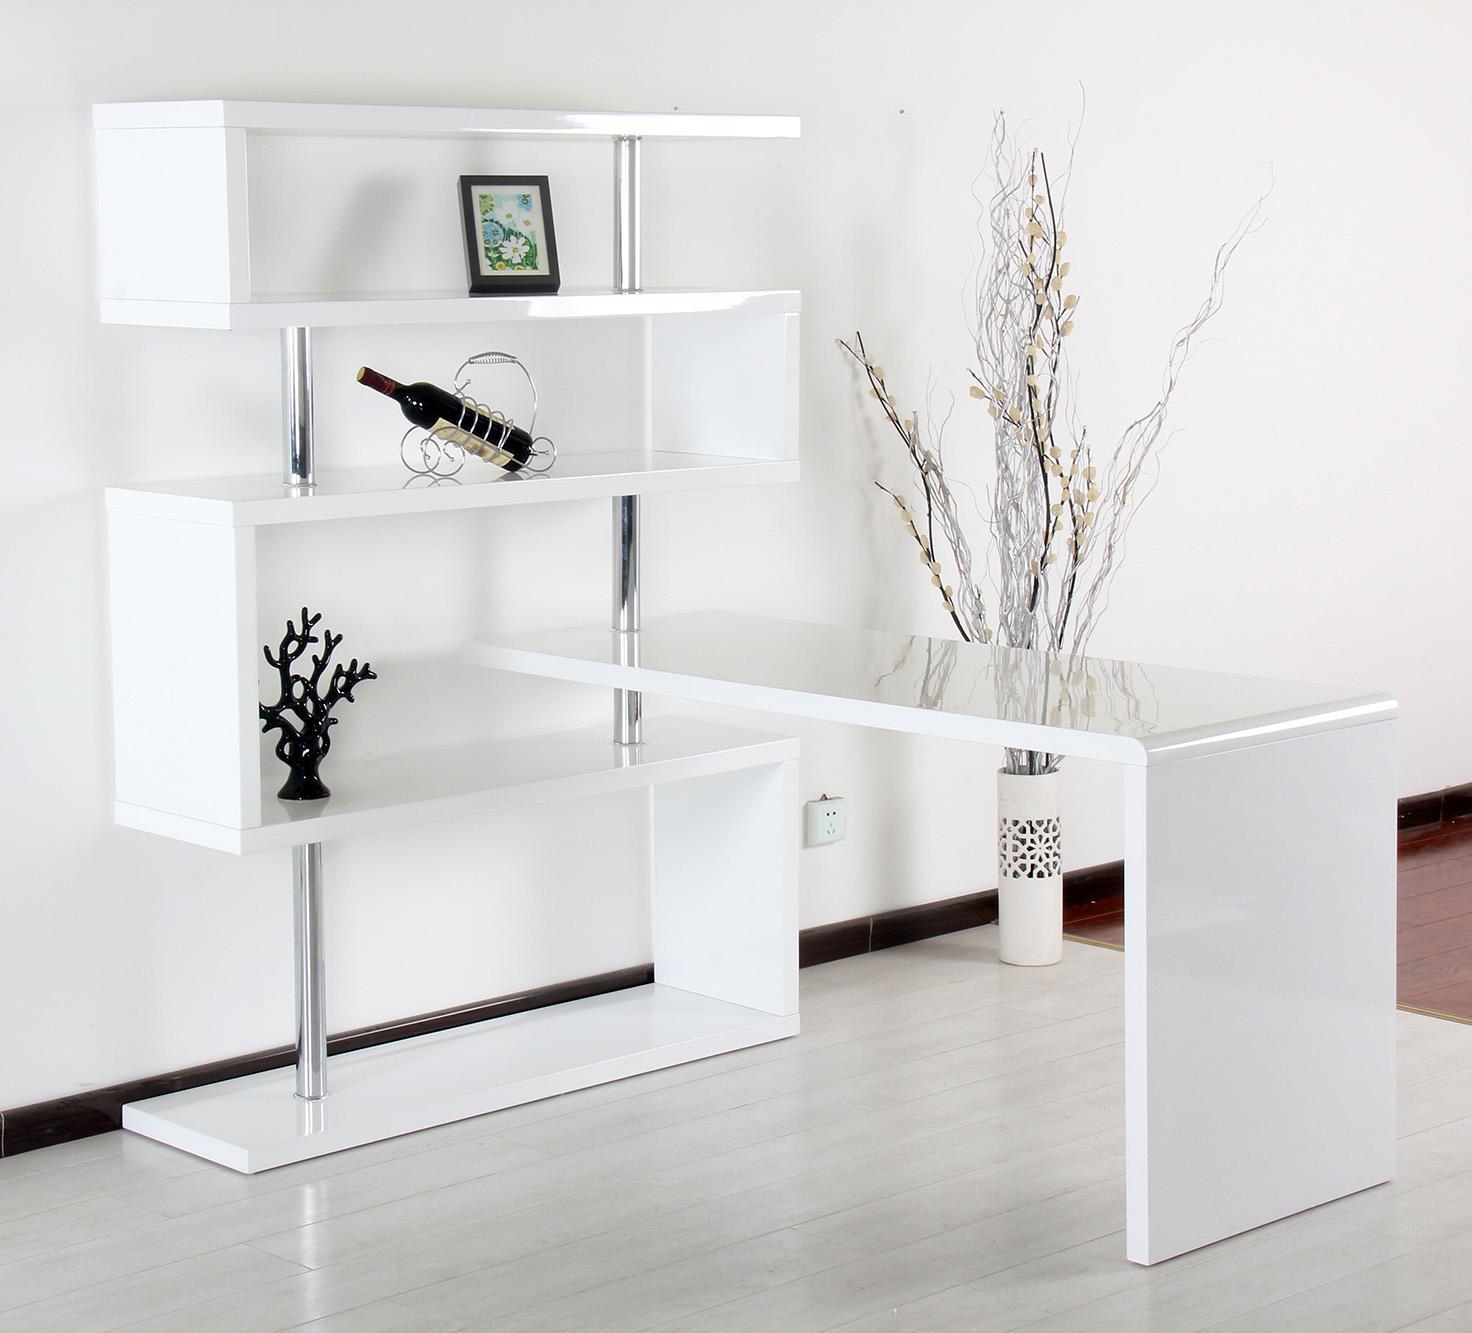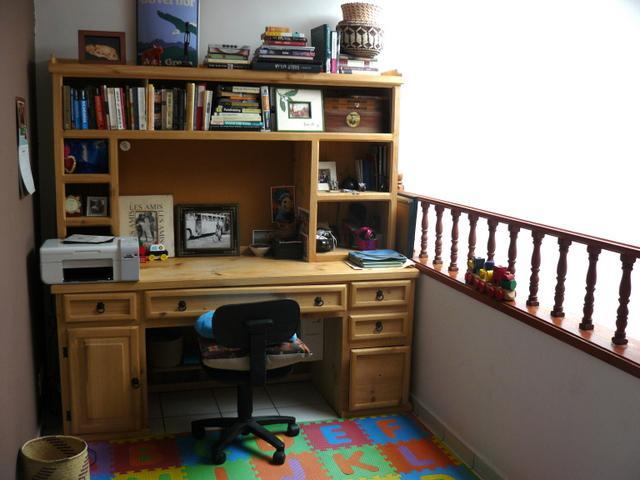The first image is the image on the left, the second image is the image on the right. For the images displayed, is the sentence "At least one desk has a white surface." factually correct? Answer yes or no. Yes. The first image is the image on the left, the second image is the image on the right. Considering the images on both sides, is "The left image shows a table that extends out from a bookshelf against a wall with divided square compartments containing some upright books." valid? Answer yes or no. No. 